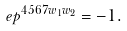Convert formula to latex. <formula><loc_0><loc_0><loc_500><loc_500>\ e p ^ { 4 5 6 7 w _ { 1 } w _ { 2 } } = - 1 .</formula> 